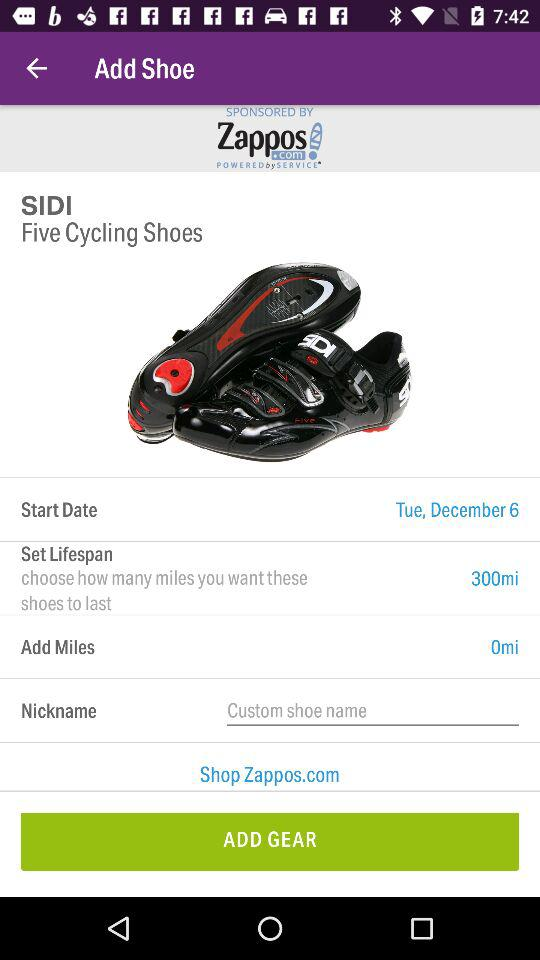What is the set lifespan? The set lifespan is 300 miles. 